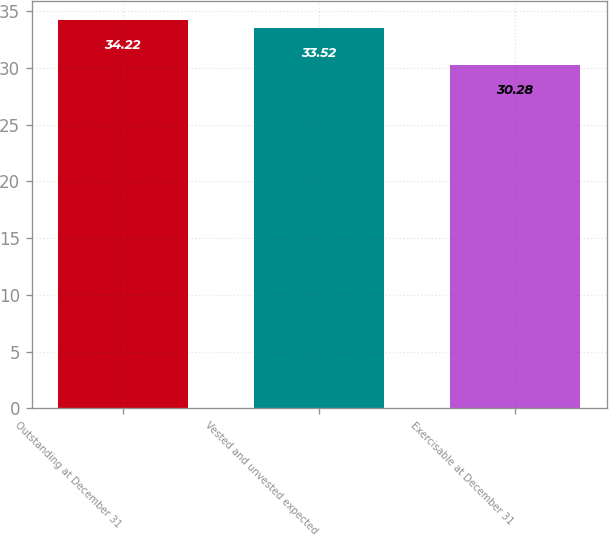Convert chart. <chart><loc_0><loc_0><loc_500><loc_500><bar_chart><fcel>Outstanding at December 31<fcel>Vested and unvested expected<fcel>Exercisable at December 31<nl><fcel>34.22<fcel>33.52<fcel>30.28<nl></chart> 